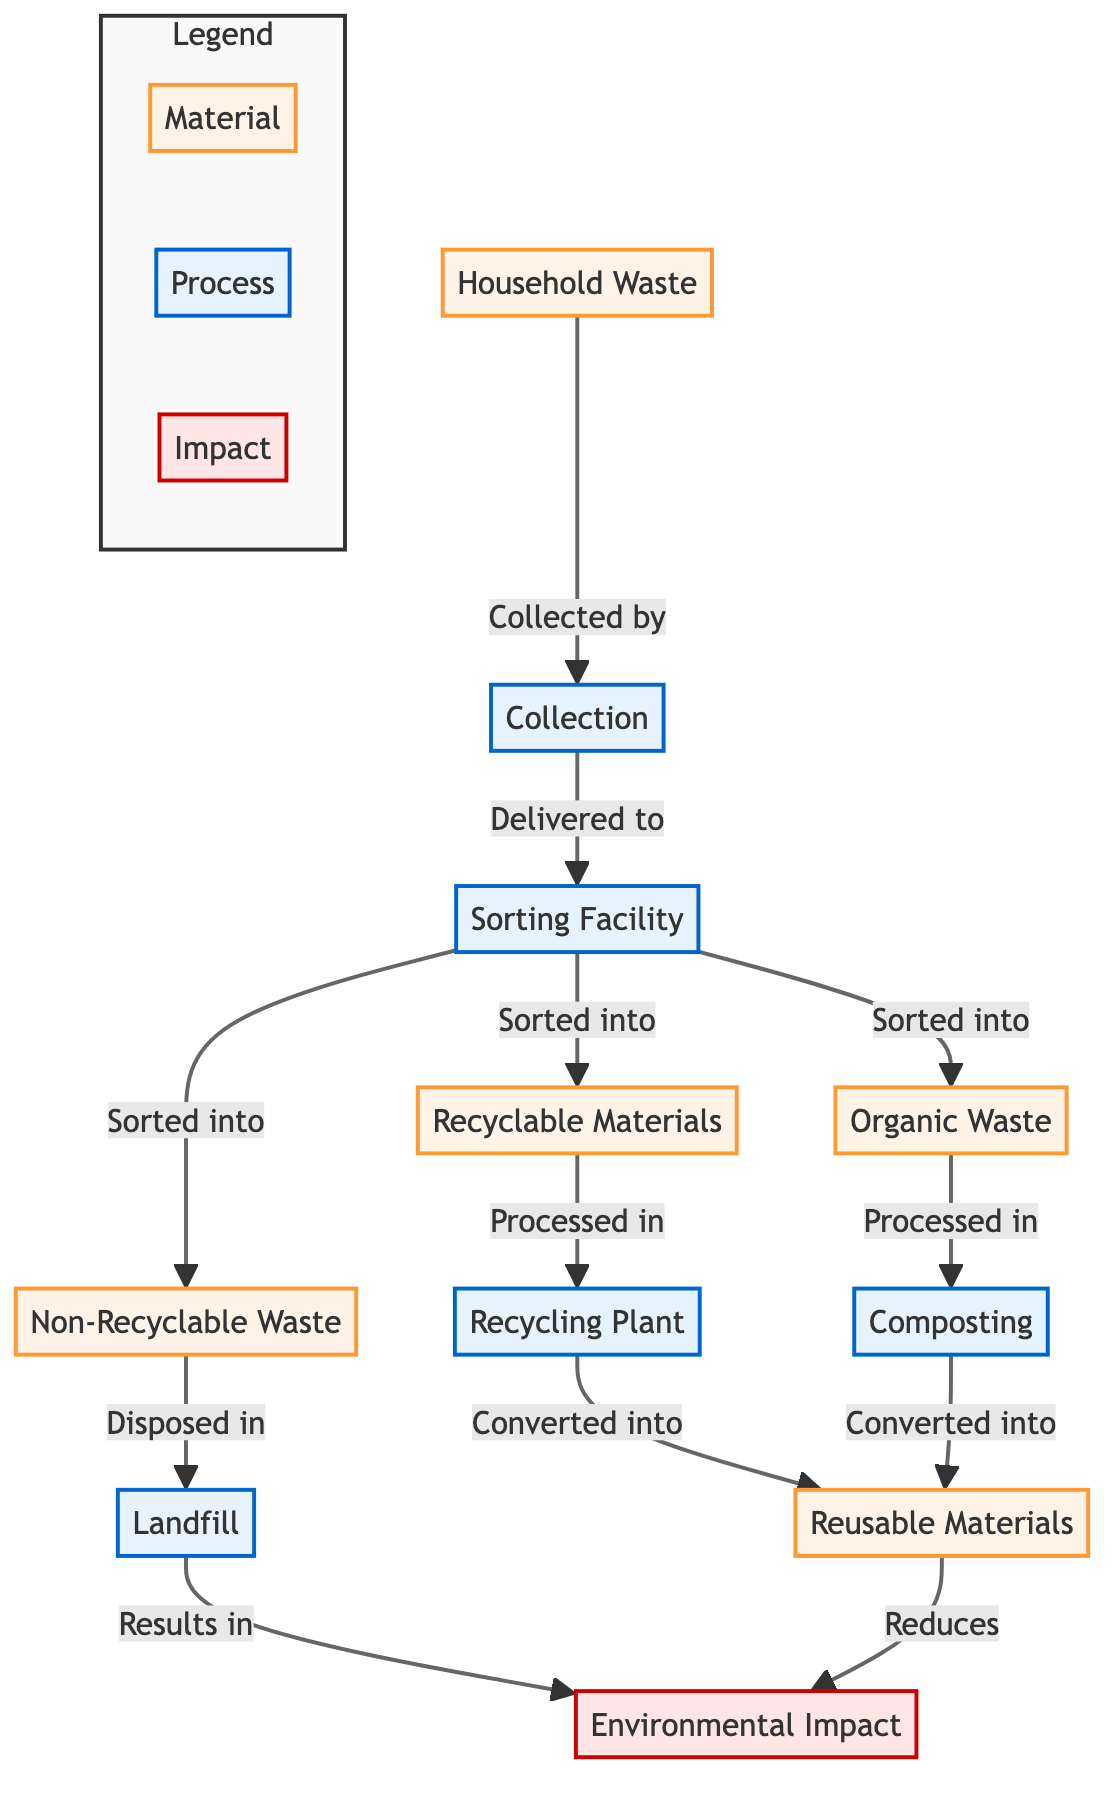What is the first step in waste management? The first step in the waste management process depicted in the diagram is "Collection," which follows the generation of "Household Waste." The flow proceeds from "Household Waste" to "Collection."
Answer: Collection How many types of waste are sorted in the sorting facility? At the sorting facility, household waste is sorted into three types: "Organic Waste," "Recyclable Materials," and "Non-Recyclable Waste." This can be seen directly from the connections in the diagram.
Answer: Three Where does organic waste go after sorting? After "Organic Waste" is sorted in the sorting facility, it is processed in "Composting," as indicated by the directed arrow. This means "Organic Waste" transitions directly to the composting process.
Answer: Composting What is the final product of recyclable materials? The final product of "Recyclable Materials" in the process is "Reusable Materials," which is achieved through the "Recycling Plant." This relationship is established in the flow from recyclable materials to the recycling plant, which leads to the production of reusable materials.
Answer: Reusable Materials What is the environmental impact of non-recyclable waste? The non-recyclable waste is disposed of in the "Landfill," which is indicated to result in "Environmental Impact." Therefore, "Non-Recyclable Waste" contributes negatively to environmental impact through its disposal.
Answer: Environmental Impact How do reusable materials affect environmental impact? "Reusable Materials" reduce "Environmental Impact," as shown by the direct connection from reusable materials indicating a positive effect in the waste management process. This points to the overall benefit that reusable materials provide towards diminishing environmental degradation.
Answer: Reduces What happens to organic waste during composting? "Organic Waste" processed in the composting phase is converted into "Reusable Materials," which is indicated by the relationship drawn from "Composting" to "Reusable Materials" in the diagram flow.
Answer: Reusable Materials What type of materials do not get recycled? "Non-Recyclable Waste" is explicitly indicated as materials that do not undergo any recycling process. This is shown through the sorting facility's direct sorting into "Non-Recyclable Waste."
Answer: Non-Recyclable Waste How is waste initially generated in the diagram? Waste is initially generated as "Household Waste," which is the starting point in the waste management process known from the initial node in the diagram.
Answer: Household Waste 